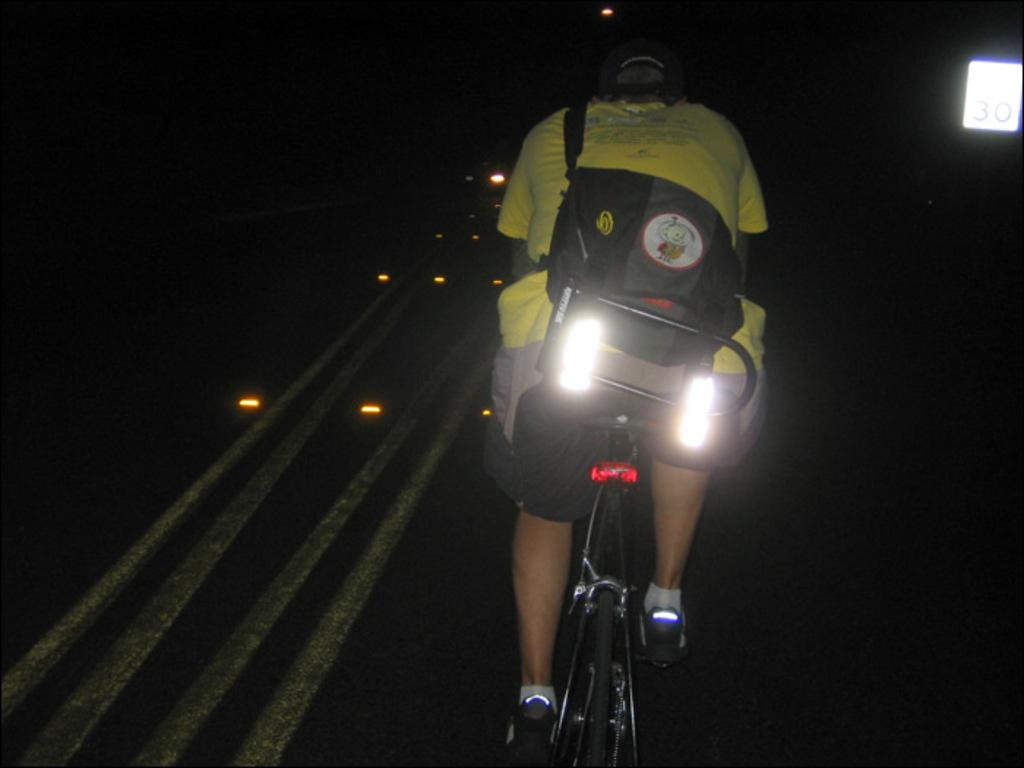Who is the main subject in the image? There is a boy in the image. What is the boy wearing? The boy is wearing a yellow t-shirt. What is the boy carrying on his back? The boy has a backpack on his back. What is the boy doing in the image? The boy is riding a bicycle. Where is the bicycle located? The bicycle is on a road. What is the color of the background in the image? The background of the image is dark. What type of door can be seen in the image? There is no door present in the image; it features a boy riding a bicycle on a road. Is the road covered in sleet in the image? The image does not provide information about the road's condition, such as whether it is covered in sleet or not. 